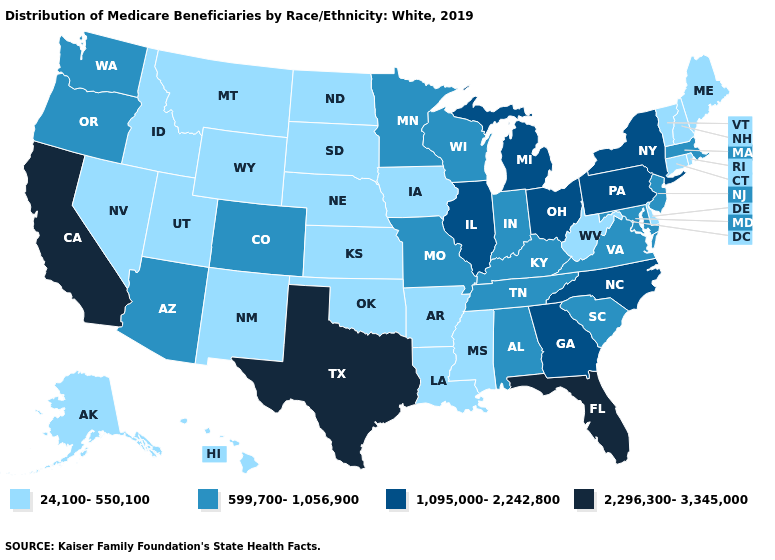What is the value of Hawaii?
Give a very brief answer. 24,100-550,100. What is the highest value in the Northeast ?
Concise answer only. 1,095,000-2,242,800. How many symbols are there in the legend?
Write a very short answer. 4. What is the value of Idaho?
Answer briefly. 24,100-550,100. What is the value of Washington?
Short answer required. 599,700-1,056,900. Name the states that have a value in the range 1,095,000-2,242,800?
Write a very short answer. Georgia, Illinois, Michigan, New York, North Carolina, Ohio, Pennsylvania. What is the highest value in states that border Wyoming?
Write a very short answer. 599,700-1,056,900. What is the value of Tennessee?
Give a very brief answer. 599,700-1,056,900. Name the states that have a value in the range 2,296,300-3,345,000?
Quick response, please. California, Florida, Texas. What is the lowest value in the South?
Concise answer only. 24,100-550,100. What is the value of Connecticut?
Concise answer only. 24,100-550,100. What is the value of New Jersey?
Short answer required. 599,700-1,056,900. Name the states that have a value in the range 2,296,300-3,345,000?
Be succinct. California, Florida, Texas. Among the states that border California , does Arizona have the lowest value?
Write a very short answer. No. Name the states that have a value in the range 1,095,000-2,242,800?
Be succinct. Georgia, Illinois, Michigan, New York, North Carolina, Ohio, Pennsylvania. 